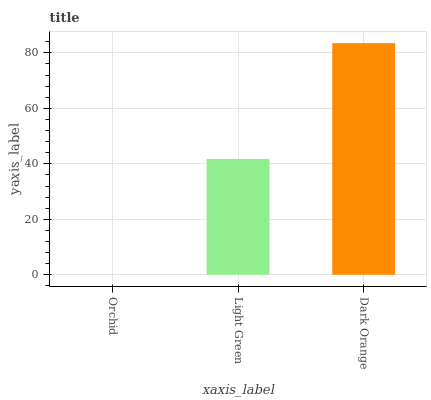Is Orchid the minimum?
Answer yes or no. Yes. Is Dark Orange the maximum?
Answer yes or no. Yes. Is Light Green the minimum?
Answer yes or no. No. Is Light Green the maximum?
Answer yes or no. No. Is Light Green greater than Orchid?
Answer yes or no. Yes. Is Orchid less than Light Green?
Answer yes or no. Yes. Is Orchid greater than Light Green?
Answer yes or no. No. Is Light Green less than Orchid?
Answer yes or no. No. Is Light Green the high median?
Answer yes or no. Yes. Is Light Green the low median?
Answer yes or no. Yes. Is Dark Orange the high median?
Answer yes or no. No. Is Orchid the low median?
Answer yes or no. No. 